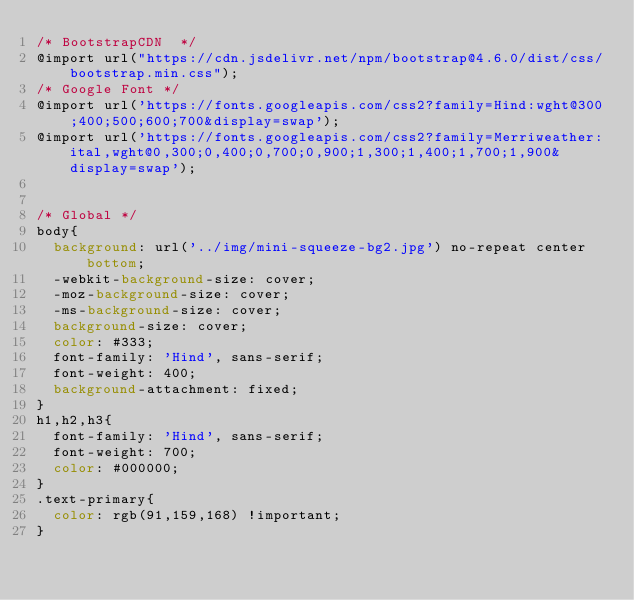<code> <loc_0><loc_0><loc_500><loc_500><_CSS_>/* BootstrapCDN  */
@import url("https://cdn.jsdelivr.net/npm/bootstrap@4.6.0/dist/css/bootstrap.min.css");
/* Google Font */
@import url('https://fonts.googleapis.com/css2?family=Hind:wght@300;400;500;600;700&display=swap');
@import url('https://fonts.googleapis.com/css2?family=Merriweather:ital,wght@0,300;0,400;0,700;0,900;1,300;1,400;1,700;1,900&display=swap');


/* Global */
body{
  background: url('../img/mini-squeeze-bg2.jpg') no-repeat center bottom;
  -webkit-background-size: cover;
  -moz-background-size: cover;
  -ms-background-size: cover;
  background-size: cover;
  color: #333;
  font-family: 'Hind', sans-serif;
  font-weight: 400;
	background-attachment: fixed;
}
h1,h2,h3{
	font-family: 'Hind', sans-serif;
  font-weight: 700;
  color: #000000;
}
.text-primary{
	color: rgb(91,159,168) !important;
}</code> 